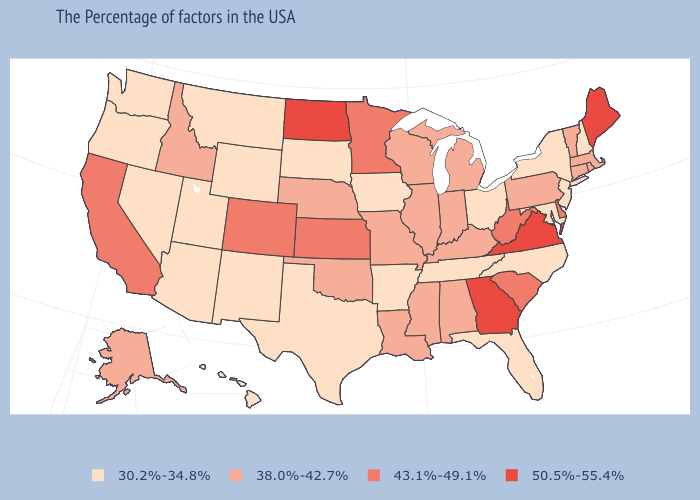What is the lowest value in states that border New Jersey?
Short answer required. 30.2%-34.8%. Does the first symbol in the legend represent the smallest category?
Be succinct. Yes. Among the states that border Pennsylvania , which have the lowest value?
Keep it brief. New York, New Jersey, Maryland, Ohio. What is the value of Vermont?
Answer briefly. 38.0%-42.7%. Name the states that have a value in the range 30.2%-34.8%?
Be succinct. New Hampshire, New York, New Jersey, Maryland, North Carolina, Ohio, Florida, Tennessee, Arkansas, Iowa, Texas, South Dakota, Wyoming, New Mexico, Utah, Montana, Arizona, Nevada, Washington, Oregon, Hawaii. What is the value of North Dakota?
Concise answer only. 50.5%-55.4%. Name the states that have a value in the range 43.1%-49.1%?
Keep it brief. Delaware, South Carolina, West Virginia, Minnesota, Kansas, Colorado, California. Does the first symbol in the legend represent the smallest category?
Write a very short answer. Yes. What is the value of Colorado?
Answer briefly. 43.1%-49.1%. Name the states that have a value in the range 50.5%-55.4%?
Write a very short answer. Maine, Virginia, Georgia, North Dakota. Does New York have a lower value than Oregon?
Give a very brief answer. No. Name the states that have a value in the range 50.5%-55.4%?
Be succinct. Maine, Virginia, Georgia, North Dakota. Among the states that border Texas , does New Mexico have the lowest value?
Short answer required. Yes. Name the states that have a value in the range 50.5%-55.4%?
Keep it brief. Maine, Virginia, Georgia, North Dakota. How many symbols are there in the legend?
Be succinct. 4. 